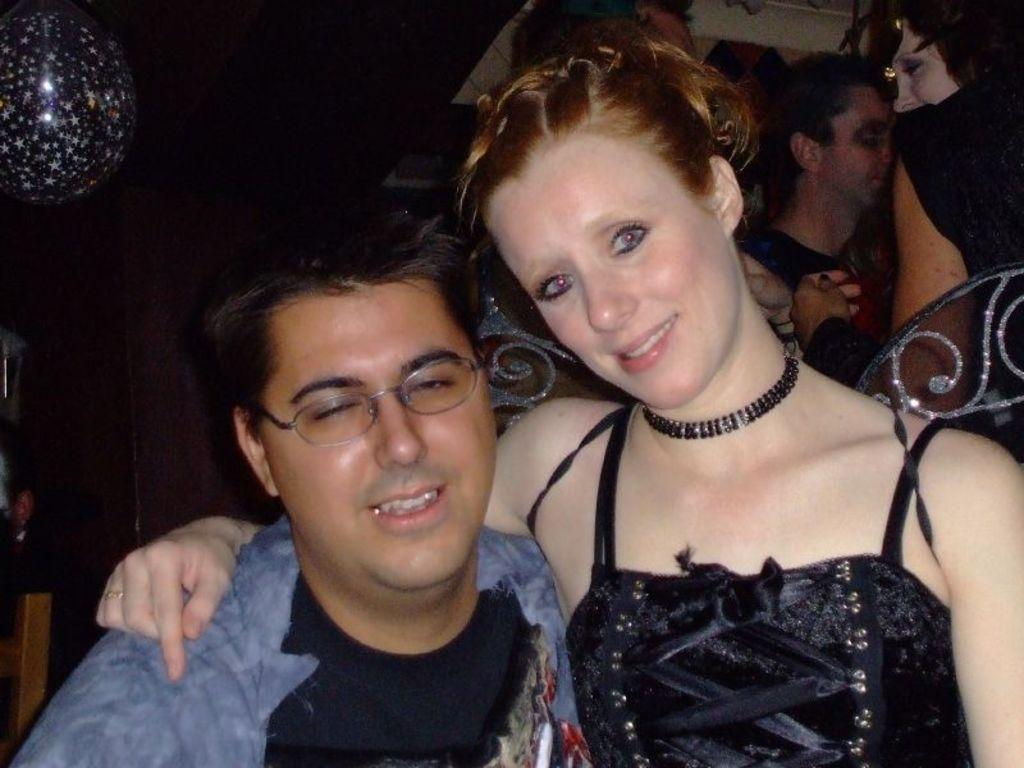What is the main subject of the image? The main subject of the image is a woman. What is the woman doing in the image? The woman is holding a man beside her. How are the woman and the man depicted in the image? Both the woman and the man are smiling. What can be seen in the background of the image? There are people, a balloon, and other objects in the background of the image. How is the background of the image described? The background view is dark. What type of stamp can be seen on the woman's forehead in the image? There is no stamp visible on the woman's forehead in the image. What is the woman using to support the stem of the flower in the image? There is no flower or stem present in the image. 